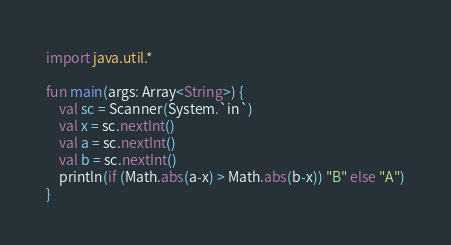Convert code to text. <code><loc_0><loc_0><loc_500><loc_500><_Kotlin_>import java.util.*

fun main(args: Array<String>) {
    val sc = Scanner(System.`in`)
    val x = sc.nextInt()
    val a = sc.nextInt()
    val b = sc.nextInt()
    println(if (Math.abs(a-x) > Math.abs(b-x)) "B" else "A")
}
</code> 